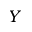<formula> <loc_0><loc_0><loc_500><loc_500>Y</formula> 